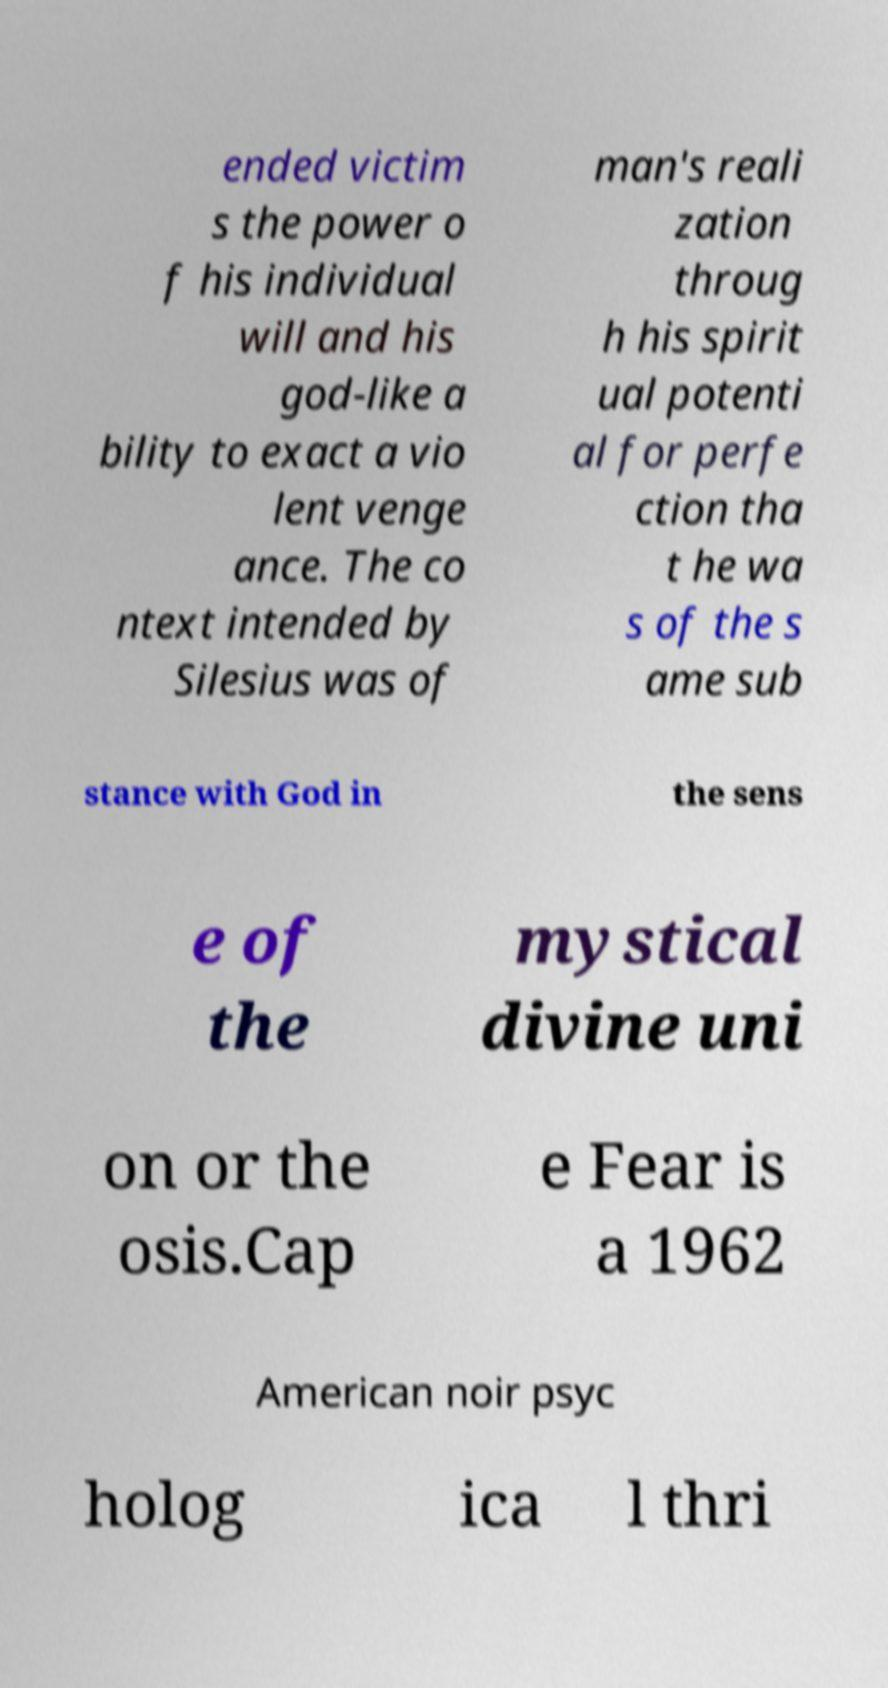Can you read and provide the text displayed in the image?This photo seems to have some interesting text. Can you extract and type it out for me? ended victim s the power o f his individual will and his god-like a bility to exact a vio lent venge ance. The co ntext intended by Silesius was of man's reali zation throug h his spirit ual potenti al for perfe ction tha t he wa s of the s ame sub stance with God in the sens e of the mystical divine uni on or the osis.Cap e Fear is a 1962 American noir psyc holog ica l thri 